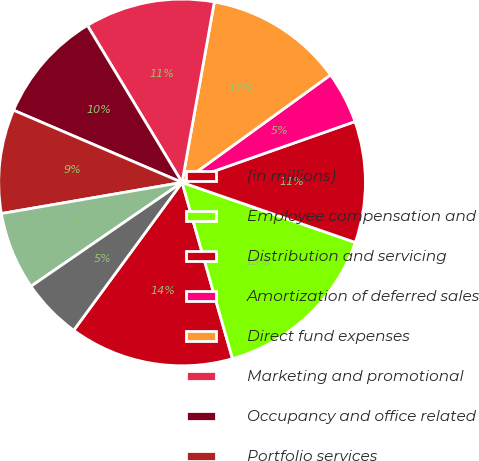Convert chart to OTSL. <chart><loc_0><loc_0><loc_500><loc_500><pie_chart><fcel>(in millions)<fcel>Employee compensation and<fcel>Distribution and servicing<fcel>Amortization of deferred sales<fcel>Direct fund expenses<fcel>Marketing and promotional<fcel>Occupancy and office related<fcel>Portfolio services<fcel>Technology<fcel>Professional services<nl><fcel>14.5%<fcel>15.26%<fcel>10.69%<fcel>4.59%<fcel>12.21%<fcel>11.45%<fcel>9.92%<fcel>9.16%<fcel>6.87%<fcel>5.35%<nl></chart> 